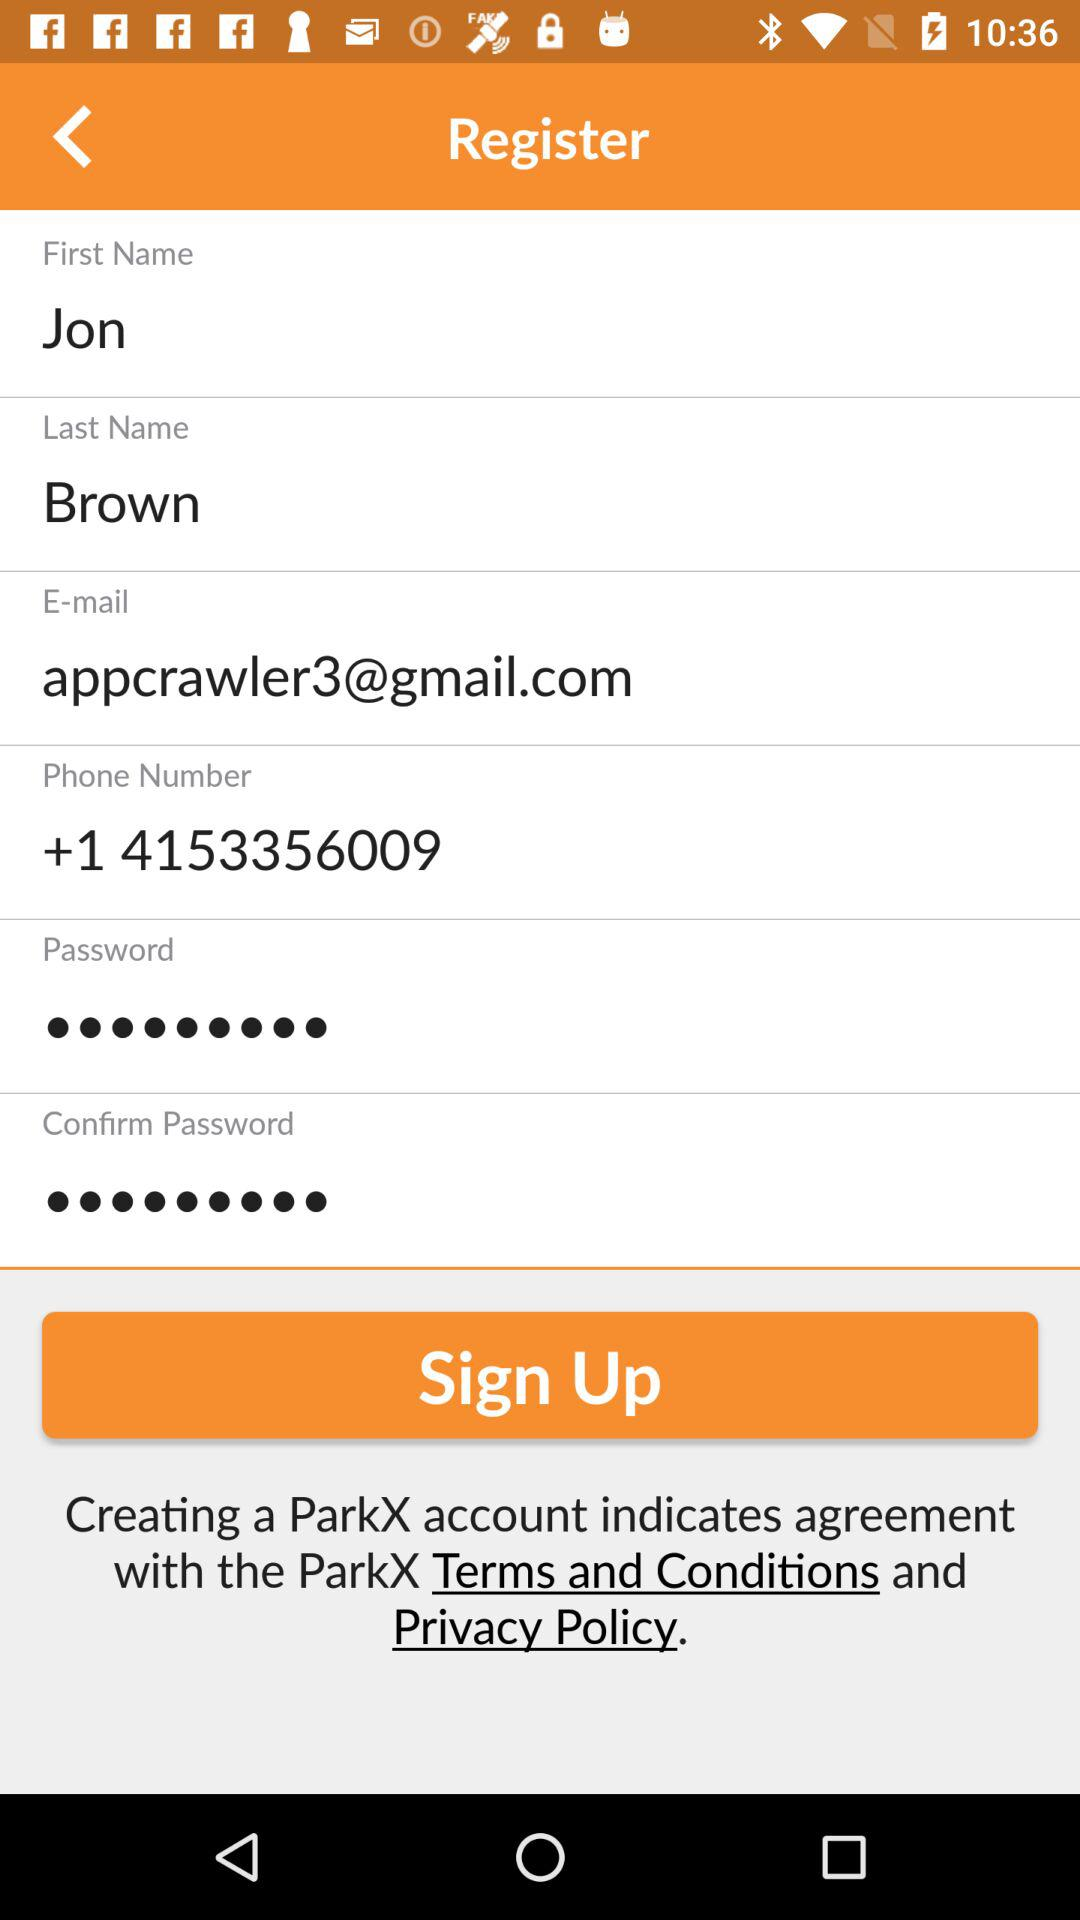What is the phone number? The phone number is "+14153356009". 